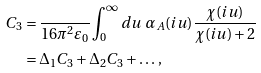Convert formula to latex. <formula><loc_0><loc_0><loc_500><loc_500>C _ { 3 } = & \, \frac { } { 1 6 \pi ^ { 2 } \varepsilon _ { 0 } } \int _ { 0 } ^ { \infty } d u \ \alpha _ { A } ( i u ) \frac { \chi ( i u ) } { \chi ( i u ) + 2 } \\ = & \, \Delta _ { 1 } C _ { 3 } + \Delta _ { 2 } C _ { 3 } + \dots \, ,</formula> 